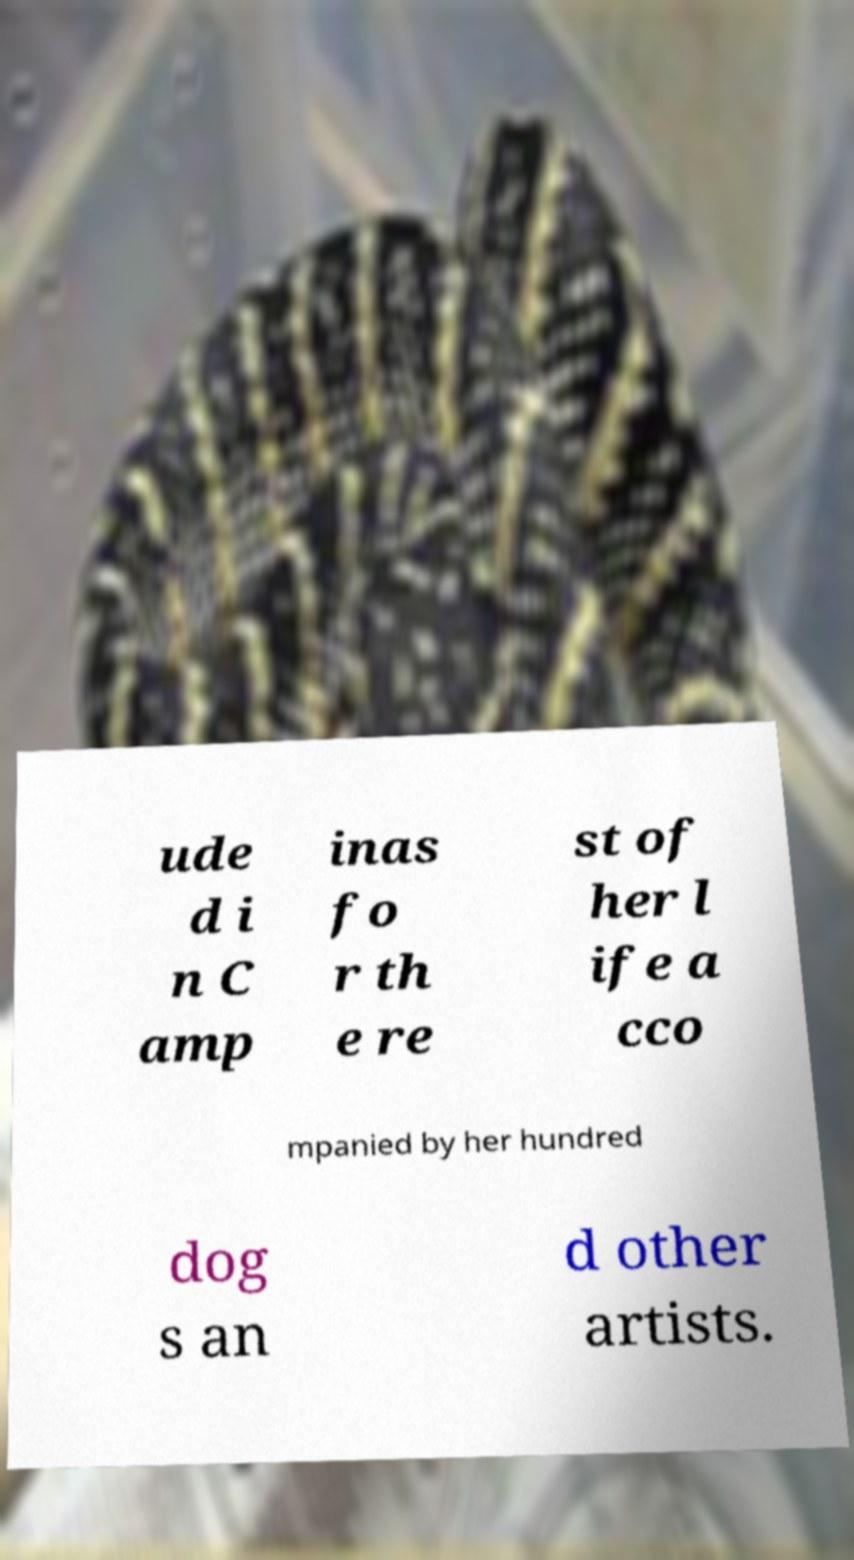Can you read and provide the text displayed in the image?This photo seems to have some interesting text. Can you extract and type it out for me? ude d i n C amp inas fo r th e re st of her l ife a cco mpanied by her hundred dog s an d other artists. 